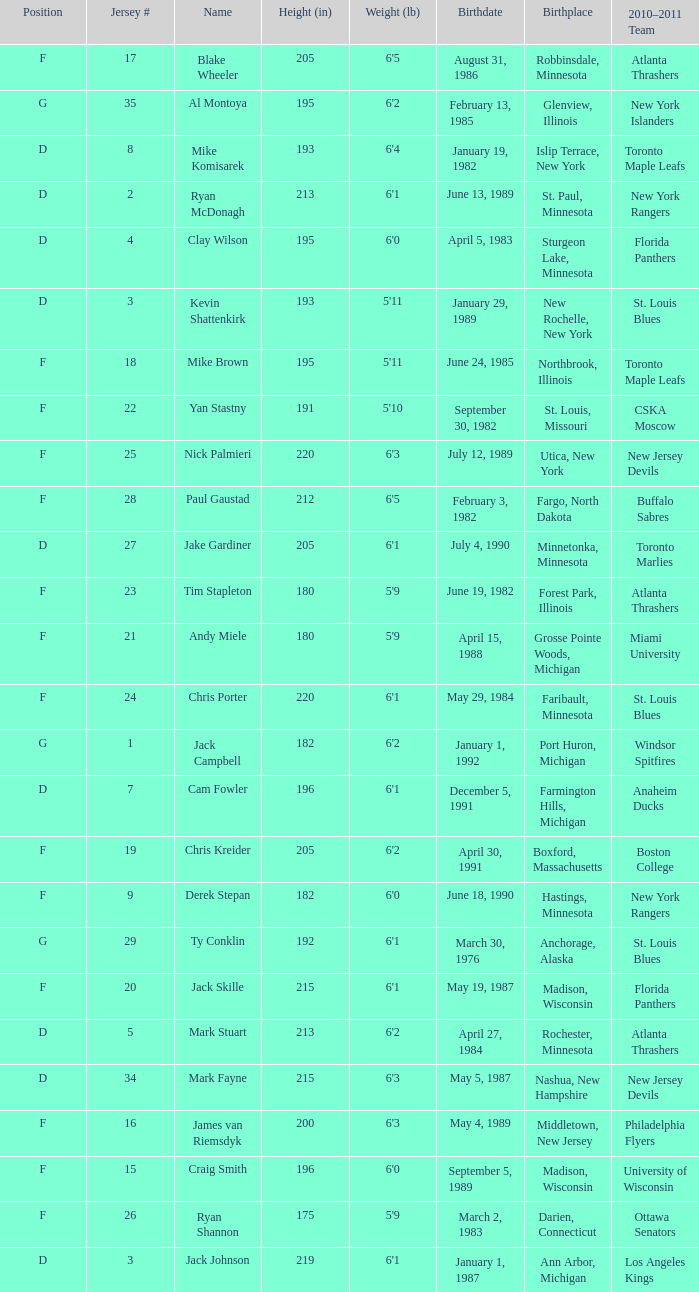Which birthplace's height in inches was more than 192 when the position was d and the birthday was April 5, 1983? Sturgeon Lake, Minnesota. 